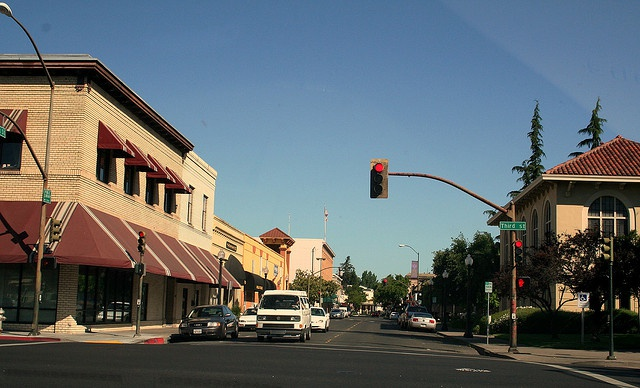Describe the objects in this image and their specific colors. I can see car in gray, black, lightyellow, and tan tones, truck in gray, black, lightyellow, and tan tones, car in gray and black tones, traffic light in gray and black tones, and car in gray, black, darkgray, and tan tones in this image. 